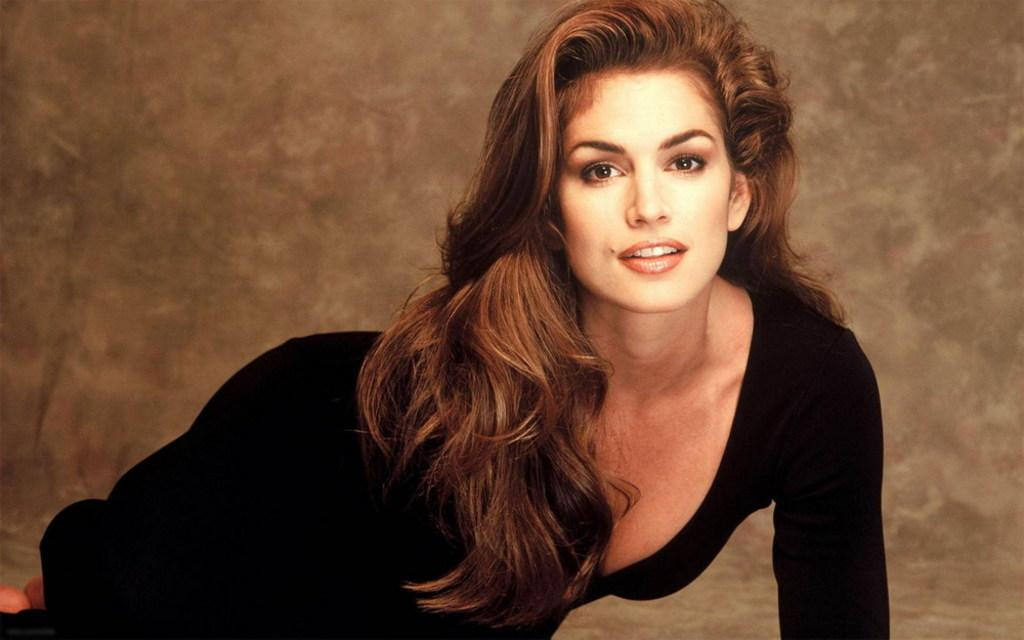What is the woman in the image doing? The woman is lying on the floor in the image. What can be seen in the background of the image? There is a wall visible in the background of the image. What type of sign is the woman holding in the image? There is no sign present in the image; the woman is simply lying on the floor. 